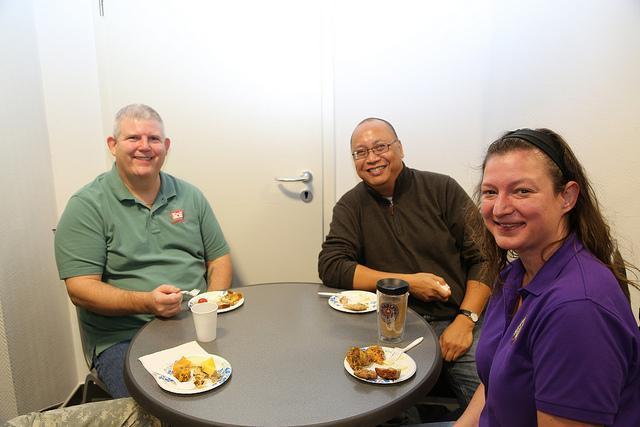How many people are there?
Give a very brief answer. 3. How many apples and oranges is on the plate?
Give a very brief answer. 0. 